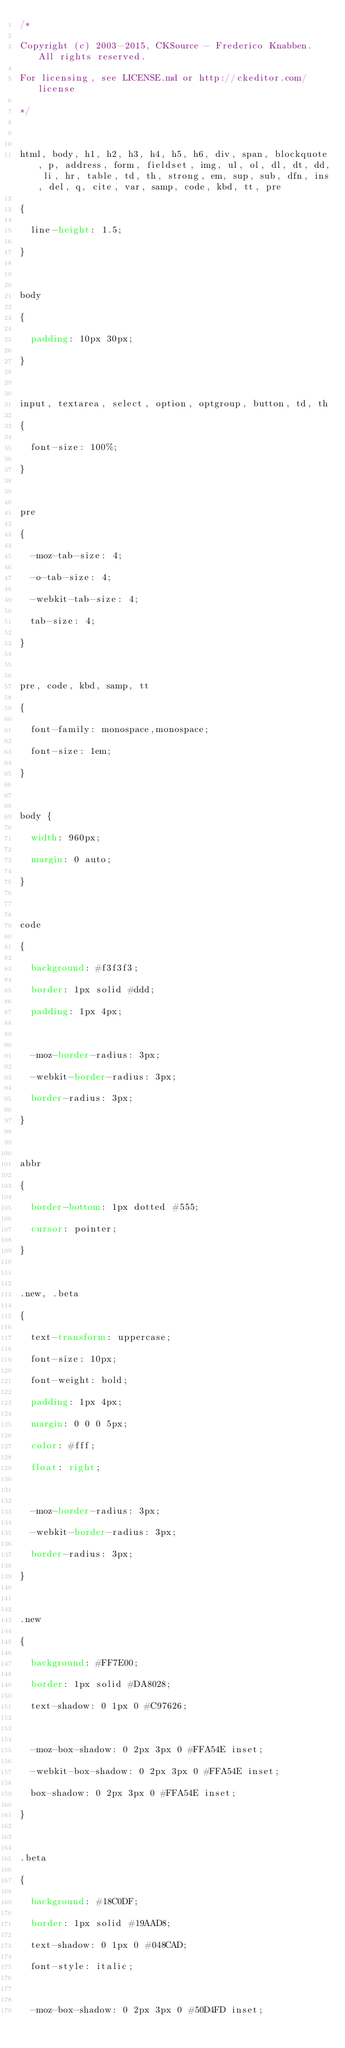<code> <loc_0><loc_0><loc_500><loc_500><_CSS_>/*
Copyright (c) 2003-2015, CKSource - Frederico Knabben. All rights reserved.
For licensing, see LICENSE.md or http://ckeditor.com/license
*/

html, body, h1, h2, h3, h4, h5, h6, div, span, blockquote, p, address, form, fieldset, img, ul, ol, dl, dt, dd, li, hr, table, td, th, strong, em, sup, sub, dfn, ins, del, q, cite, var, samp, code, kbd, tt, pre
{
	line-height: 1.5;
}

body
{
	padding: 10px 30px;
}

input, textarea, select, option, optgroup, button, td, th
{
	font-size: 100%;
}

pre
{
	-moz-tab-size: 4;
	-o-tab-size: 4;
	-webkit-tab-size: 4;
	tab-size: 4;
}

pre, code, kbd, samp, tt
{
	font-family: monospace,monospace;
	font-size: 1em;
}

body {
	width: 960px;
	margin: 0 auto;
}

code
{
	background: #f3f3f3;
	border: 1px solid #ddd;
	padding: 1px 4px;

	-moz-border-radius: 3px;
	-webkit-border-radius: 3px;
	border-radius: 3px;
}

abbr
{
	border-bottom: 1px dotted #555;
	cursor: pointer;
}

.new, .beta
{
	text-transform: uppercase;
	font-size: 10px;
	font-weight: bold;
	padding: 1px 4px;
	margin: 0 0 0 5px;
	color: #fff;
	float: right;

	-moz-border-radius: 3px;
	-webkit-border-radius: 3px;
	border-radius: 3px;
}

.new
{
	background: #FF7E00;
	border: 1px solid #DA8028;
	text-shadow: 0 1px 0 #C97626;

	-moz-box-shadow: 0 2px 3px 0 #FFA54E inset;
	-webkit-box-shadow: 0 2px 3px 0 #FFA54E inset;
	box-shadow: 0 2px 3px 0 #FFA54E inset;
}

.beta
{
	background: #18C0DF;
	border: 1px solid #19AAD8;
	text-shadow: 0 1px 0 #048CAD;
	font-style: italic;

	-moz-box-shadow: 0 2px 3px 0 #50D4FD inset;</code> 